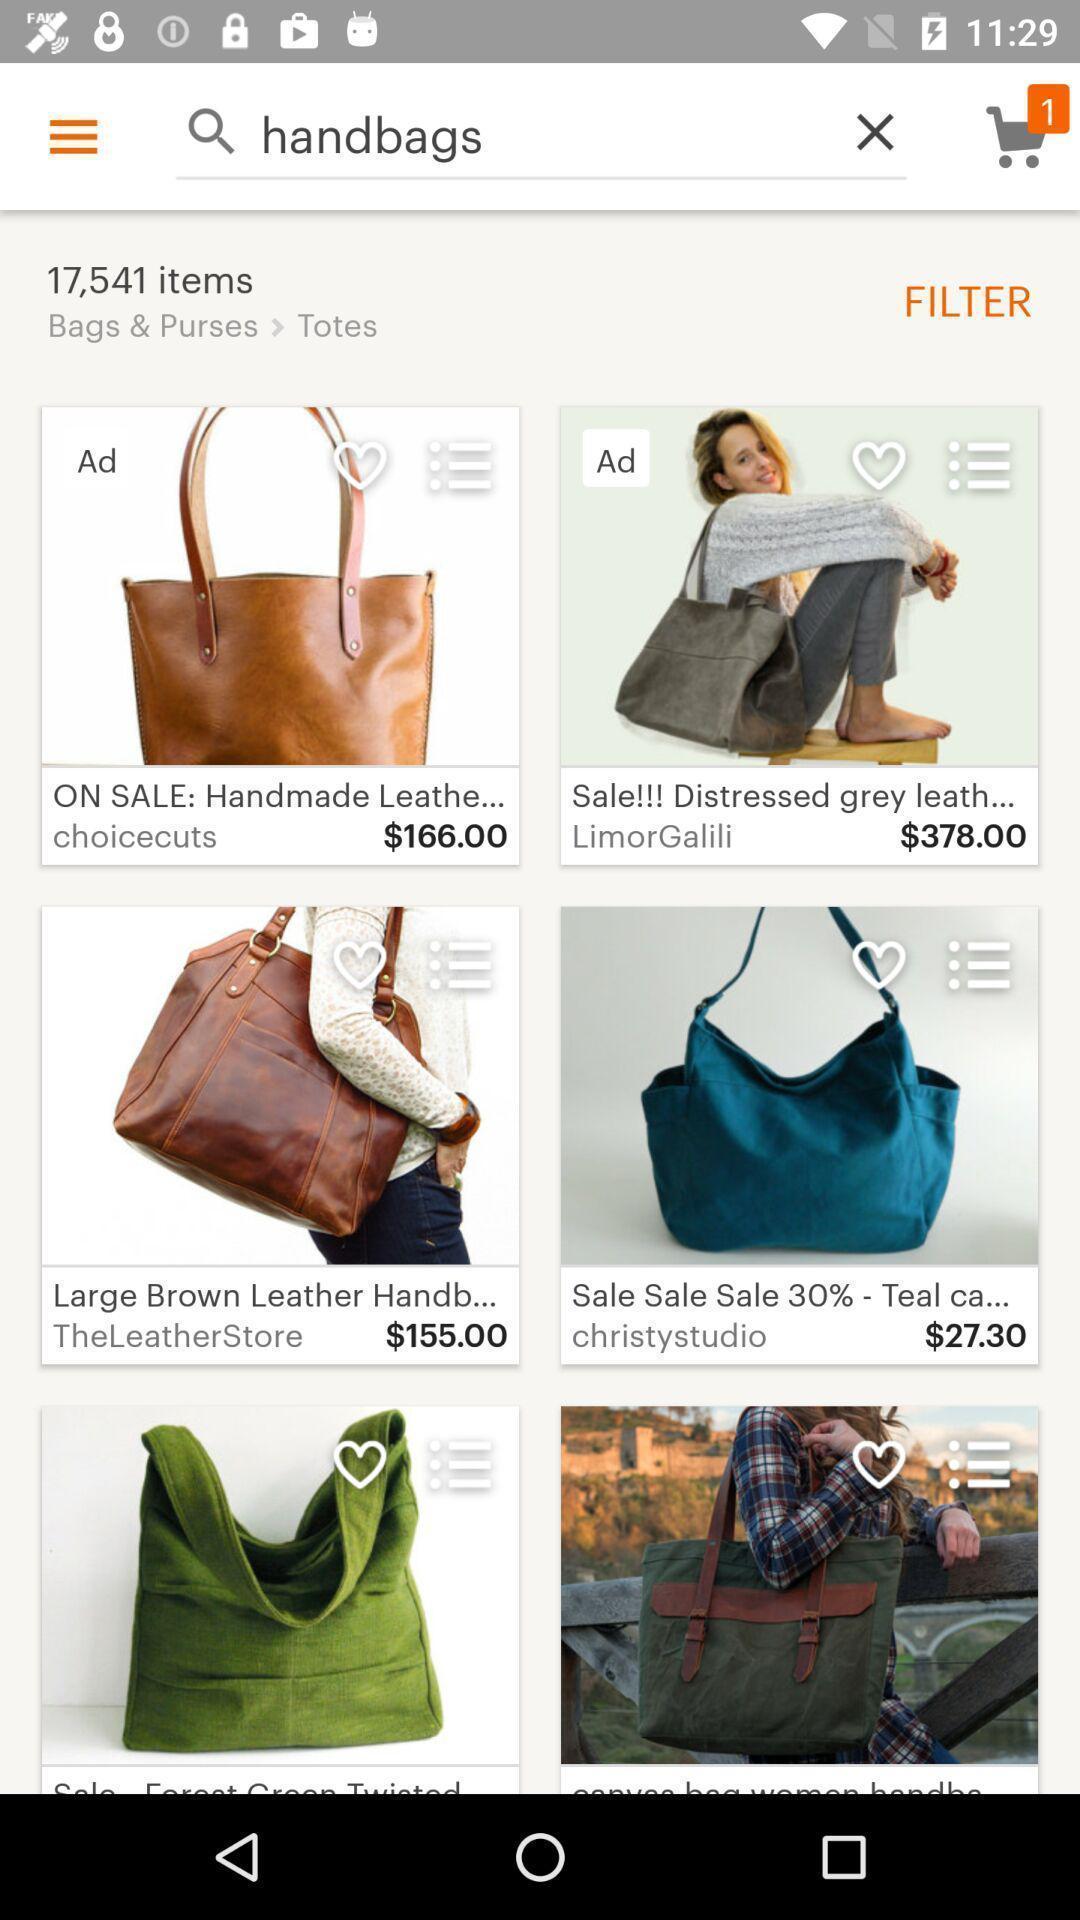Give me a narrative description of this picture. Page showing the products list in shopping app. 